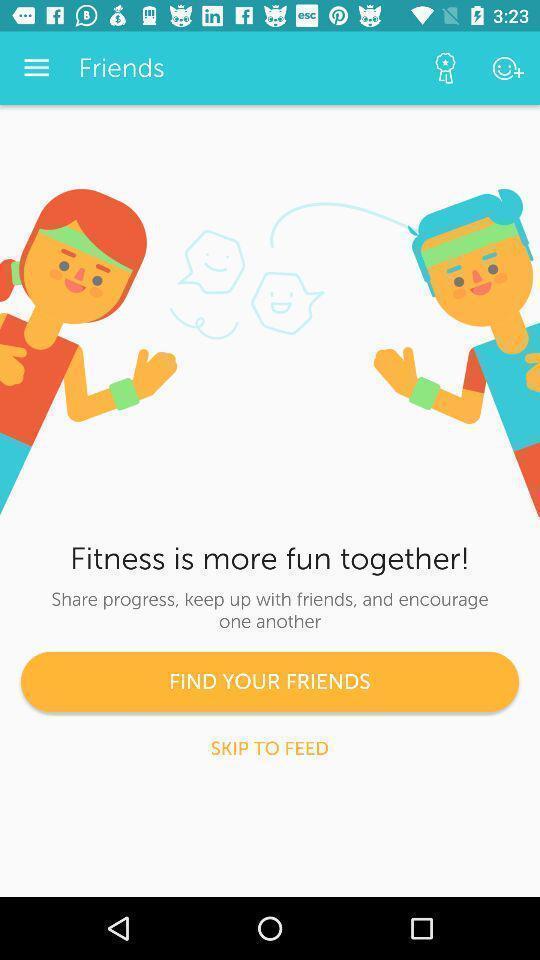Summarize the information in this screenshot. Welcome page of a fitness app. 